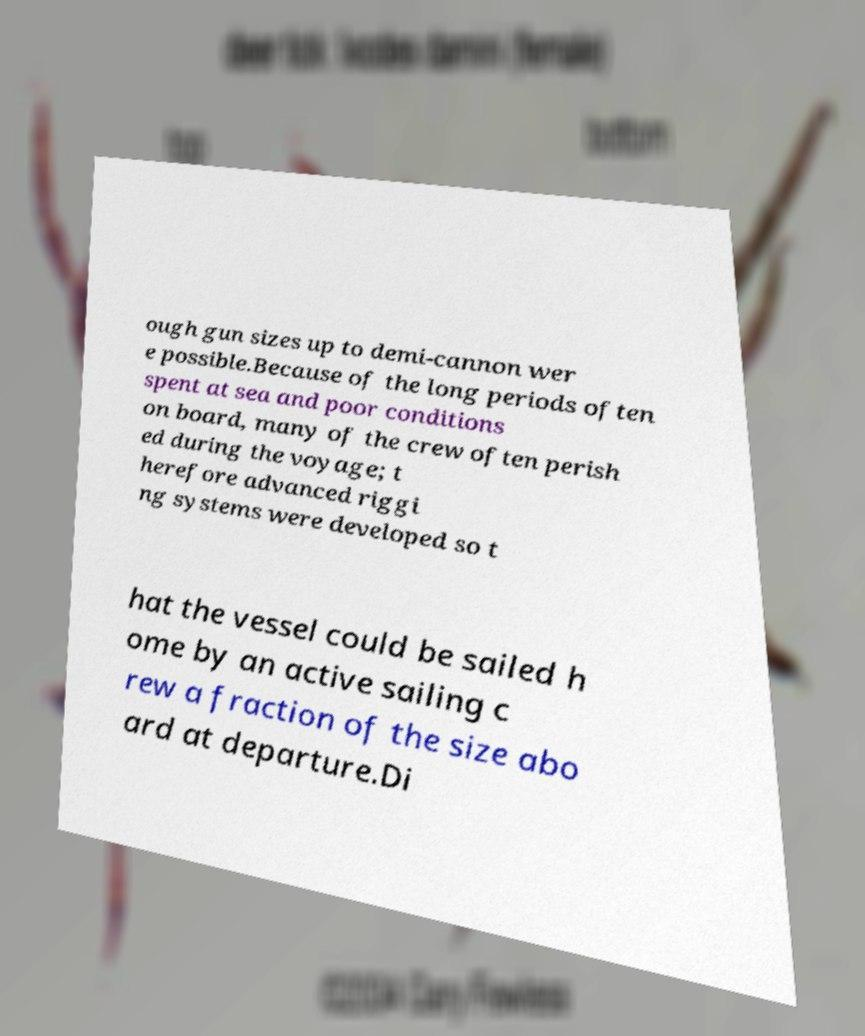I need the written content from this picture converted into text. Can you do that? ough gun sizes up to demi-cannon wer e possible.Because of the long periods often spent at sea and poor conditions on board, many of the crew often perish ed during the voyage; t herefore advanced riggi ng systems were developed so t hat the vessel could be sailed h ome by an active sailing c rew a fraction of the size abo ard at departure.Di 